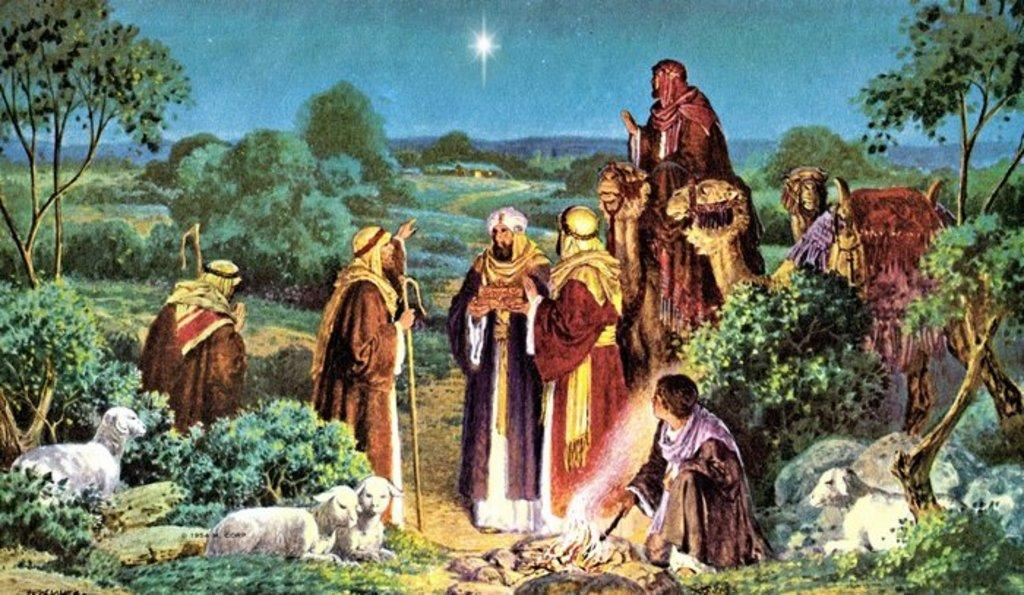What type of artwork is depicted in the image? The image is a painting. What subjects are included in the painting? There are people and animals in the painting. What can be seen in the background of the painting? There are trees, hills, and the sky visible in the background of the painting. How many eggs are present in the painting? There are no eggs visible in the painting; it features people, animals, trees, hills, and the sky. What type of authority is depicted in the painting? There is no authority figure depicted in the painting; it focuses on people, animals, trees, hills, and the sky. 